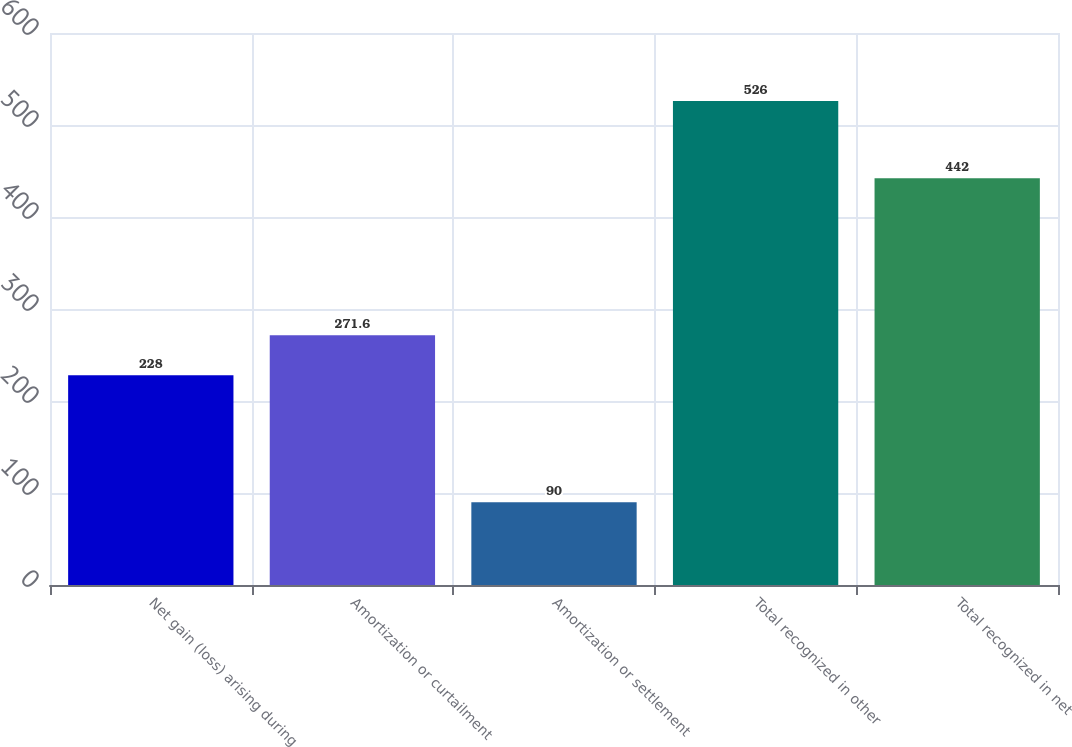<chart> <loc_0><loc_0><loc_500><loc_500><bar_chart><fcel>Net gain (loss) arising during<fcel>Amortization or curtailment<fcel>Amortization or settlement<fcel>Total recognized in other<fcel>Total recognized in net<nl><fcel>228<fcel>271.6<fcel>90<fcel>526<fcel>442<nl></chart> 